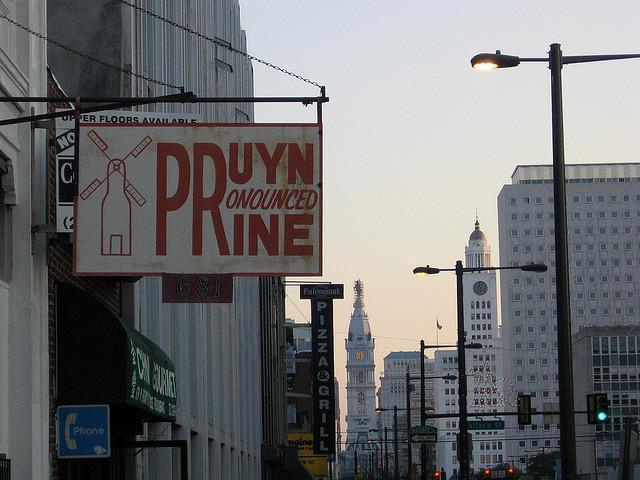Which way is illegal to turn on the upcoming cross street?
Pick the right solution, then justify: 'Answer: answer
Rationale: rationale.'
Options: Right, straight, none, left. Answer: right.
Rationale: There is a sign showing the upcoming cross street is a one-way street requiring vehicles to only turn to the left. 